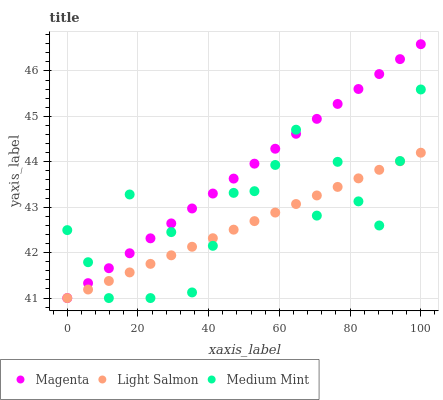Does Light Salmon have the minimum area under the curve?
Answer yes or no. Yes. Does Magenta have the maximum area under the curve?
Answer yes or no. Yes. Does Magenta have the minimum area under the curve?
Answer yes or no. No. Does Light Salmon have the maximum area under the curve?
Answer yes or no. No. Is Light Salmon the smoothest?
Answer yes or no. Yes. Is Medium Mint the roughest?
Answer yes or no. Yes. Is Magenta the smoothest?
Answer yes or no. No. Is Magenta the roughest?
Answer yes or no. No. Does Medium Mint have the lowest value?
Answer yes or no. Yes. Does Magenta have the highest value?
Answer yes or no. Yes. Does Light Salmon have the highest value?
Answer yes or no. No. Does Medium Mint intersect Light Salmon?
Answer yes or no. Yes. Is Medium Mint less than Light Salmon?
Answer yes or no. No. Is Medium Mint greater than Light Salmon?
Answer yes or no. No. 